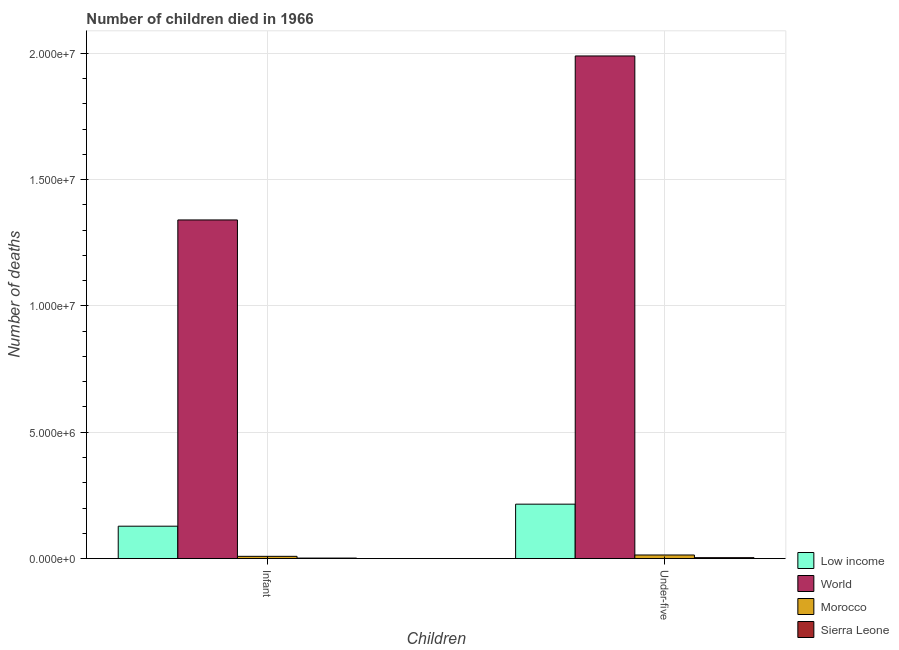How many different coloured bars are there?
Keep it short and to the point. 4. Are the number of bars per tick equal to the number of legend labels?
Offer a terse response. Yes. What is the label of the 2nd group of bars from the left?
Offer a very short reply. Under-five. What is the number of infant deaths in World?
Provide a short and direct response. 1.34e+07. Across all countries, what is the maximum number of infant deaths?
Keep it short and to the point. 1.34e+07. Across all countries, what is the minimum number of infant deaths?
Keep it short and to the point. 2.00e+04. In which country was the number of under-five deaths maximum?
Give a very brief answer. World. In which country was the number of infant deaths minimum?
Your response must be concise. Sierra Leone. What is the total number of infant deaths in the graph?
Offer a very short reply. 1.48e+07. What is the difference between the number of infant deaths in Sierra Leone and that in Low income?
Keep it short and to the point. -1.26e+06. What is the difference between the number of under-five deaths in Low income and the number of infant deaths in Morocco?
Your response must be concise. 2.06e+06. What is the average number of infant deaths per country?
Provide a succinct answer. 3.70e+06. What is the difference between the number of infant deaths and number of under-five deaths in Low income?
Your answer should be compact. -8.72e+05. What is the ratio of the number of infant deaths in Sierra Leone to that in Low income?
Provide a short and direct response. 0.02. Is the number of infant deaths in Low income less than that in World?
Offer a terse response. Yes. In how many countries, is the number of under-five deaths greater than the average number of under-five deaths taken over all countries?
Offer a very short reply. 1. What does the 2nd bar from the left in Under-five represents?
Keep it short and to the point. World. What does the 2nd bar from the right in Under-five represents?
Keep it short and to the point. Morocco. How many bars are there?
Offer a very short reply. 8. How many countries are there in the graph?
Your answer should be very brief. 4. What is the difference between two consecutive major ticks on the Y-axis?
Give a very brief answer. 5.00e+06. Are the values on the major ticks of Y-axis written in scientific E-notation?
Offer a terse response. Yes. Does the graph contain any zero values?
Offer a very short reply. No. How many legend labels are there?
Offer a terse response. 4. How are the legend labels stacked?
Offer a very short reply. Vertical. What is the title of the graph?
Your response must be concise. Number of children died in 1966. Does "Turkey" appear as one of the legend labels in the graph?
Ensure brevity in your answer.  No. What is the label or title of the X-axis?
Give a very brief answer. Children. What is the label or title of the Y-axis?
Your answer should be compact. Number of deaths. What is the Number of deaths of Low income in Infant?
Provide a short and direct response. 1.28e+06. What is the Number of deaths in World in Infant?
Give a very brief answer. 1.34e+07. What is the Number of deaths of Morocco in Infant?
Offer a very short reply. 8.85e+04. What is the Number of deaths of Sierra Leone in Infant?
Give a very brief answer. 2.00e+04. What is the Number of deaths in Low income in Under-five?
Make the answer very short. 2.15e+06. What is the Number of deaths in World in Under-five?
Give a very brief answer. 1.99e+07. What is the Number of deaths in Morocco in Under-five?
Ensure brevity in your answer.  1.41e+05. What is the Number of deaths of Sierra Leone in Under-five?
Ensure brevity in your answer.  3.61e+04. Across all Children, what is the maximum Number of deaths of Low income?
Provide a short and direct response. 2.15e+06. Across all Children, what is the maximum Number of deaths of World?
Keep it short and to the point. 1.99e+07. Across all Children, what is the maximum Number of deaths in Morocco?
Give a very brief answer. 1.41e+05. Across all Children, what is the maximum Number of deaths in Sierra Leone?
Make the answer very short. 3.61e+04. Across all Children, what is the minimum Number of deaths of Low income?
Make the answer very short. 1.28e+06. Across all Children, what is the minimum Number of deaths of World?
Your response must be concise. 1.34e+07. Across all Children, what is the minimum Number of deaths of Morocco?
Provide a short and direct response. 8.85e+04. Across all Children, what is the minimum Number of deaths of Sierra Leone?
Your answer should be compact. 2.00e+04. What is the total Number of deaths in Low income in the graph?
Your response must be concise. 3.43e+06. What is the total Number of deaths of World in the graph?
Make the answer very short. 3.33e+07. What is the total Number of deaths in Morocco in the graph?
Offer a very short reply. 2.30e+05. What is the total Number of deaths of Sierra Leone in the graph?
Give a very brief answer. 5.61e+04. What is the difference between the Number of deaths of Low income in Infant and that in Under-five?
Your response must be concise. -8.72e+05. What is the difference between the Number of deaths in World in Infant and that in Under-five?
Provide a short and direct response. -6.49e+06. What is the difference between the Number of deaths of Morocco in Infant and that in Under-five?
Provide a short and direct response. -5.28e+04. What is the difference between the Number of deaths in Sierra Leone in Infant and that in Under-five?
Your answer should be compact. -1.61e+04. What is the difference between the Number of deaths of Low income in Infant and the Number of deaths of World in Under-five?
Ensure brevity in your answer.  -1.86e+07. What is the difference between the Number of deaths in Low income in Infant and the Number of deaths in Morocco in Under-five?
Give a very brief answer. 1.14e+06. What is the difference between the Number of deaths of Low income in Infant and the Number of deaths of Sierra Leone in Under-five?
Ensure brevity in your answer.  1.25e+06. What is the difference between the Number of deaths in World in Infant and the Number of deaths in Morocco in Under-five?
Your response must be concise. 1.33e+07. What is the difference between the Number of deaths in World in Infant and the Number of deaths in Sierra Leone in Under-five?
Your answer should be compact. 1.34e+07. What is the difference between the Number of deaths in Morocco in Infant and the Number of deaths in Sierra Leone in Under-five?
Your answer should be compact. 5.24e+04. What is the average Number of deaths of Low income per Children?
Your answer should be very brief. 1.72e+06. What is the average Number of deaths of World per Children?
Provide a succinct answer. 1.66e+07. What is the average Number of deaths of Morocco per Children?
Offer a terse response. 1.15e+05. What is the average Number of deaths in Sierra Leone per Children?
Offer a very short reply. 2.80e+04. What is the difference between the Number of deaths of Low income and Number of deaths of World in Infant?
Your response must be concise. -1.21e+07. What is the difference between the Number of deaths of Low income and Number of deaths of Morocco in Infant?
Your answer should be very brief. 1.19e+06. What is the difference between the Number of deaths in Low income and Number of deaths in Sierra Leone in Infant?
Give a very brief answer. 1.26e+06. What is the difference between the Number of deaths in World and Number of deaths in Morocco in Infant?
Give a very brief answer. 1.33e+07. What is the difference between the Number of deaths in World and Number of deaths in Sierra Leone in Infant?
Your answer should be very brief. 1.34e+07. What is the difference between the Number of deaths of Morocco and Number of deaths of Sierra Leone in Infant?
Make the answer very short. 6.85e+04. What is the difference between the Number of deaths in Low income and Number of deaths in World in Under-five?
Offer a terse response. -1.77e+07. What is the difference between the Number of deaths in Low income and Number of deaths in Morocco in Under-five?
Your answer should be compact. 2.01e+06. What is the difference between the Number of deaths in Low income and Number of deaths in Sierra Leone in Under-five?
Your answer should be very brief. 2.12e+06. What is the difference between the Number of deaths of World and Number of deaths of Morocco in Under-five?
Your response must be concise. 1.98e+07. What is the difference between the Number of deaths in World and Number of deaths in Sierra Leone in Under-five?
Make the answer very short. 1.99e+07. What is the difference between the Number of deaths in Morocco and Number of deaths in Sierra Leone in Under-five?
Provide a succinct answer. 1.05e+05. What is the ratio of the Number of deaths in Low income in Infant to that in Under-five?
Offer a very short reply. 0.59. What is the ratio of the Number of deaths of World in Infant to that in Under-five?
Make the answer very short. 0.67. What is the ratio of the Number of deaths of Morocco in Infant to that in Under-five?
Provide a short and direct response. 0.63. What is the ratio of the Number of deaths of Sierra Leone in Infant to that in Under-five?
Your answer should be compact. 0.55. What is the difference between the highest and the second highest Number of deaths of Low income?
Make the answer very short. 8.72e+05. What is the difference between the highest and the second highest Number of deaths of World?
Ensure brevity in your answer.  6.49e+06. What is the difference between the highest and the second highest Number of deaths of Morocco?
Provide a short and direct response. 5.28e+04. What is the difference between the highest and the second highest Number of deaths of Sierra Leone?
Ensure brevity in your answer.  1.61e+04. What is the difference between the highest and the lowest Number of deaths in Low income?
Your answer should be very brief. 8.72e+05. What is the difference between the highest and the lowest Number of deaths in World?
Provide a succinct answer. 6.49e+06. What is the difference between the highest and the lowest Number of deaths in Morocco?
Offer a terse response. 5.28e+04. What is the difference between the highest and the lowest Number of deaths in Sierra Leone?
Make the answer very short. 1.61e+04. 